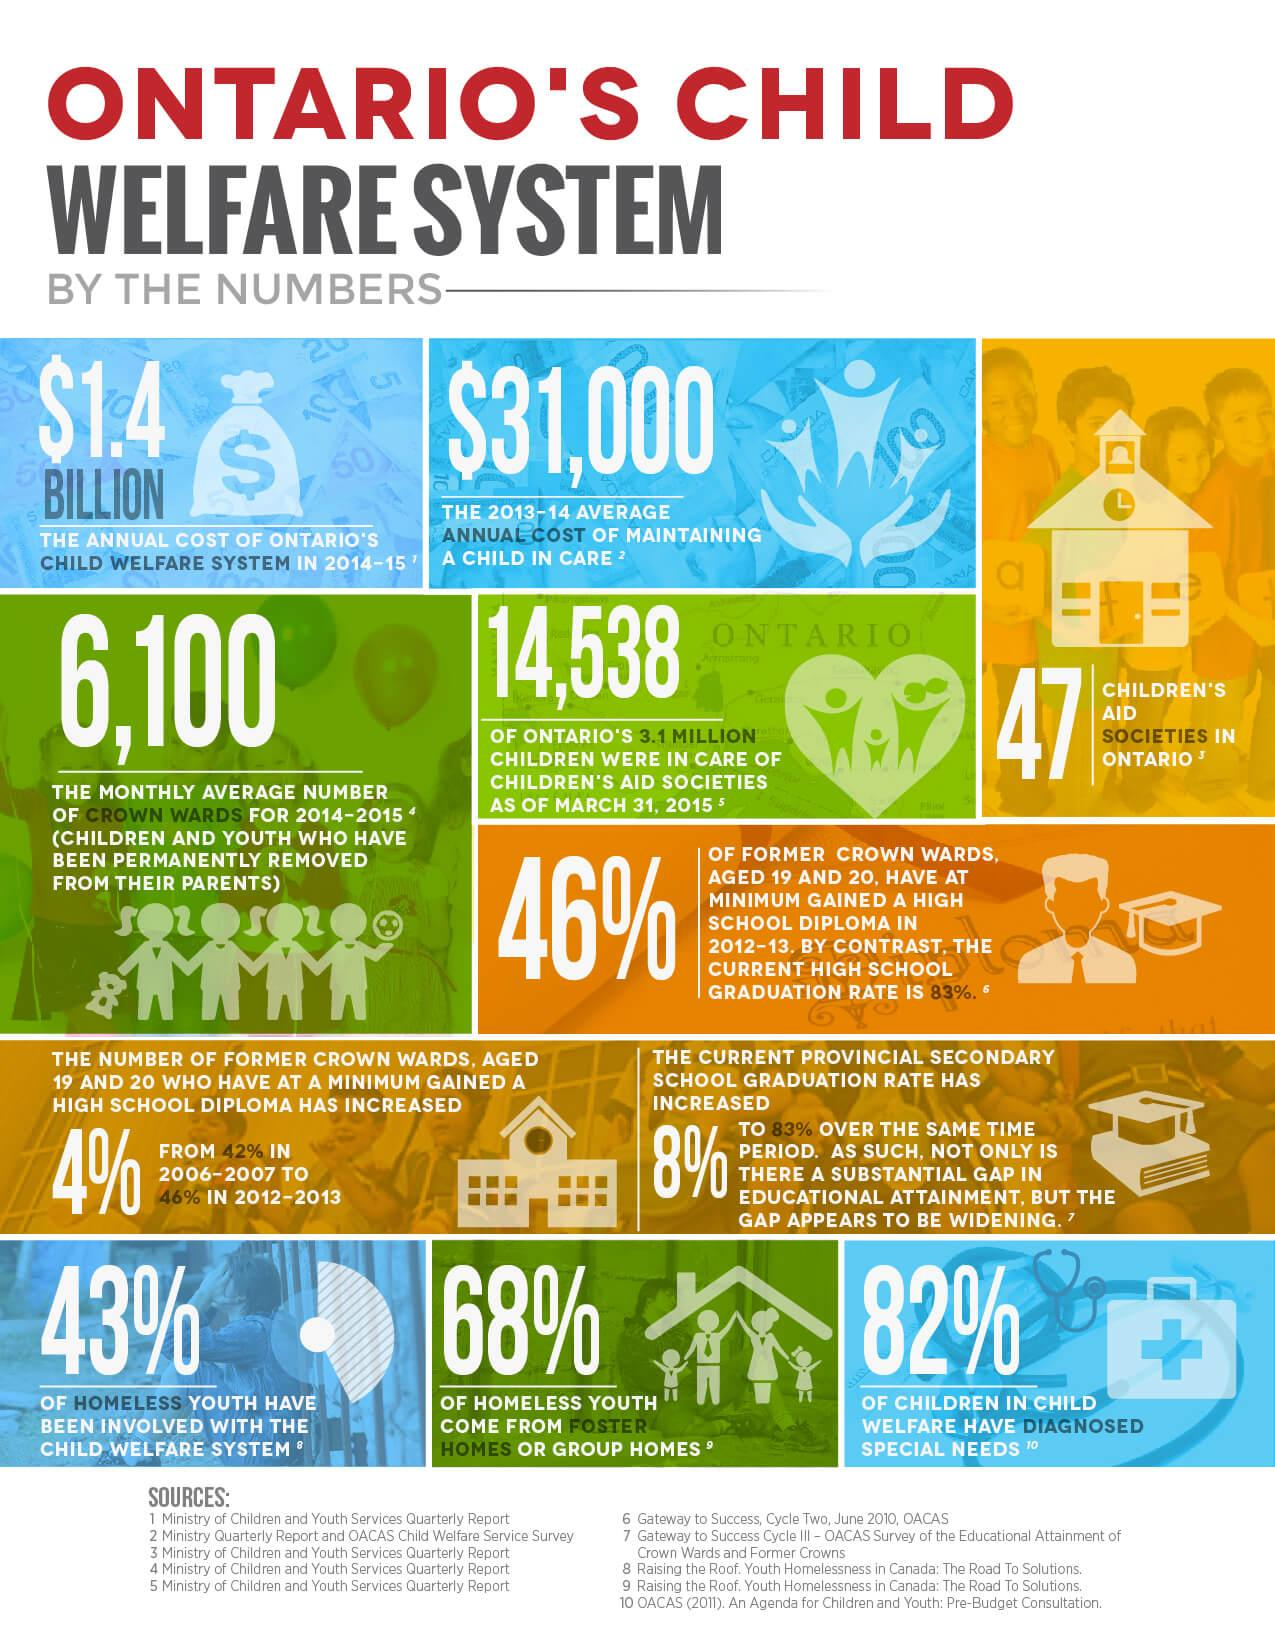Point out several critical features in this image. According to a recent study, 68% of homeless youth have come from group homes, indicating that group homes may be a significant factor in the homelessness of young people. According to recent research, a majority of homeless youth, 57%, have not had prior involvement with the child welfare system. According to recent data, only 18% of children in child welfare have not been diagnosed with special needs. 